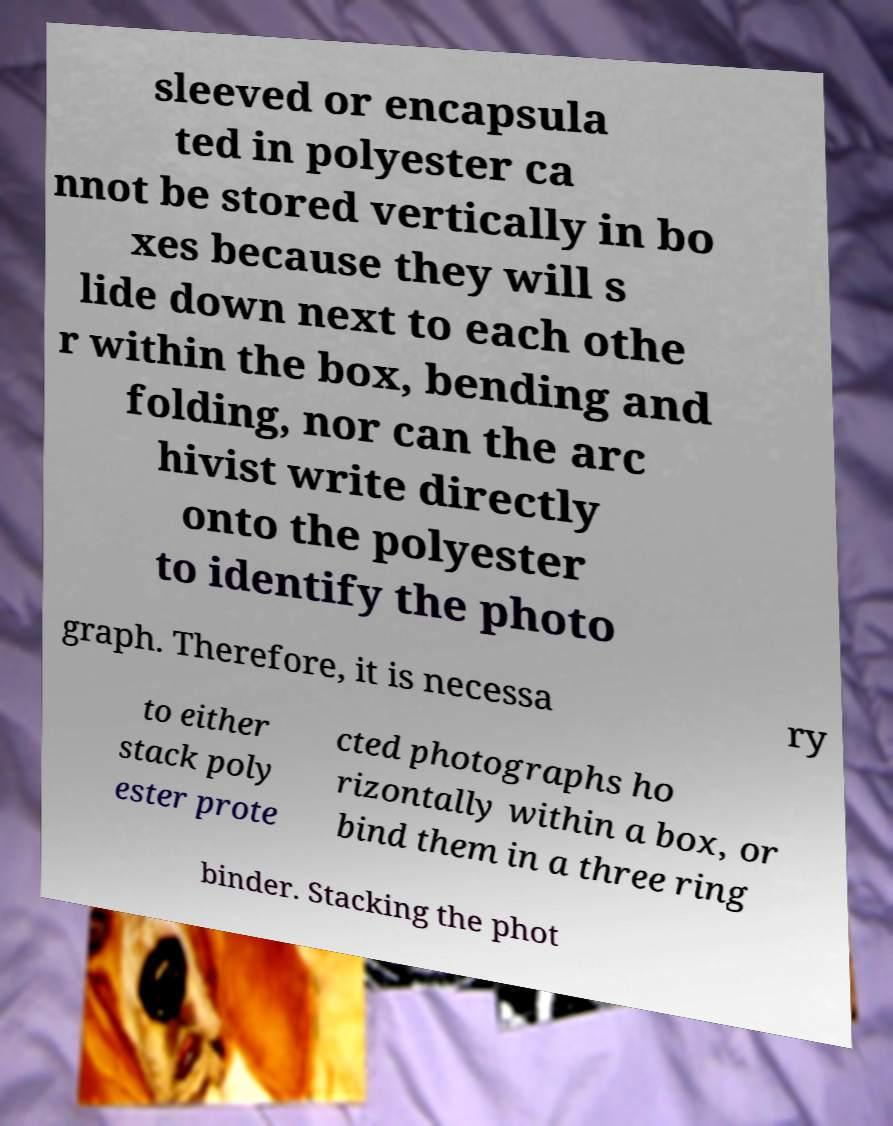Can you accurately transcribe the text from the provided image for me? sleeved or encapsula ted in polyester ca nnot be stored vertically in bo xes because they will s lide down next to each othe r within the box, bending and folding, nor can the arc hivist write directly onto the polyester to identify the photo graph. Therefore, it is necessa ry to either stack poly ester prote cted photographs ho rizontally within a box, or bind them in a three ring binder. Stacking the phot 